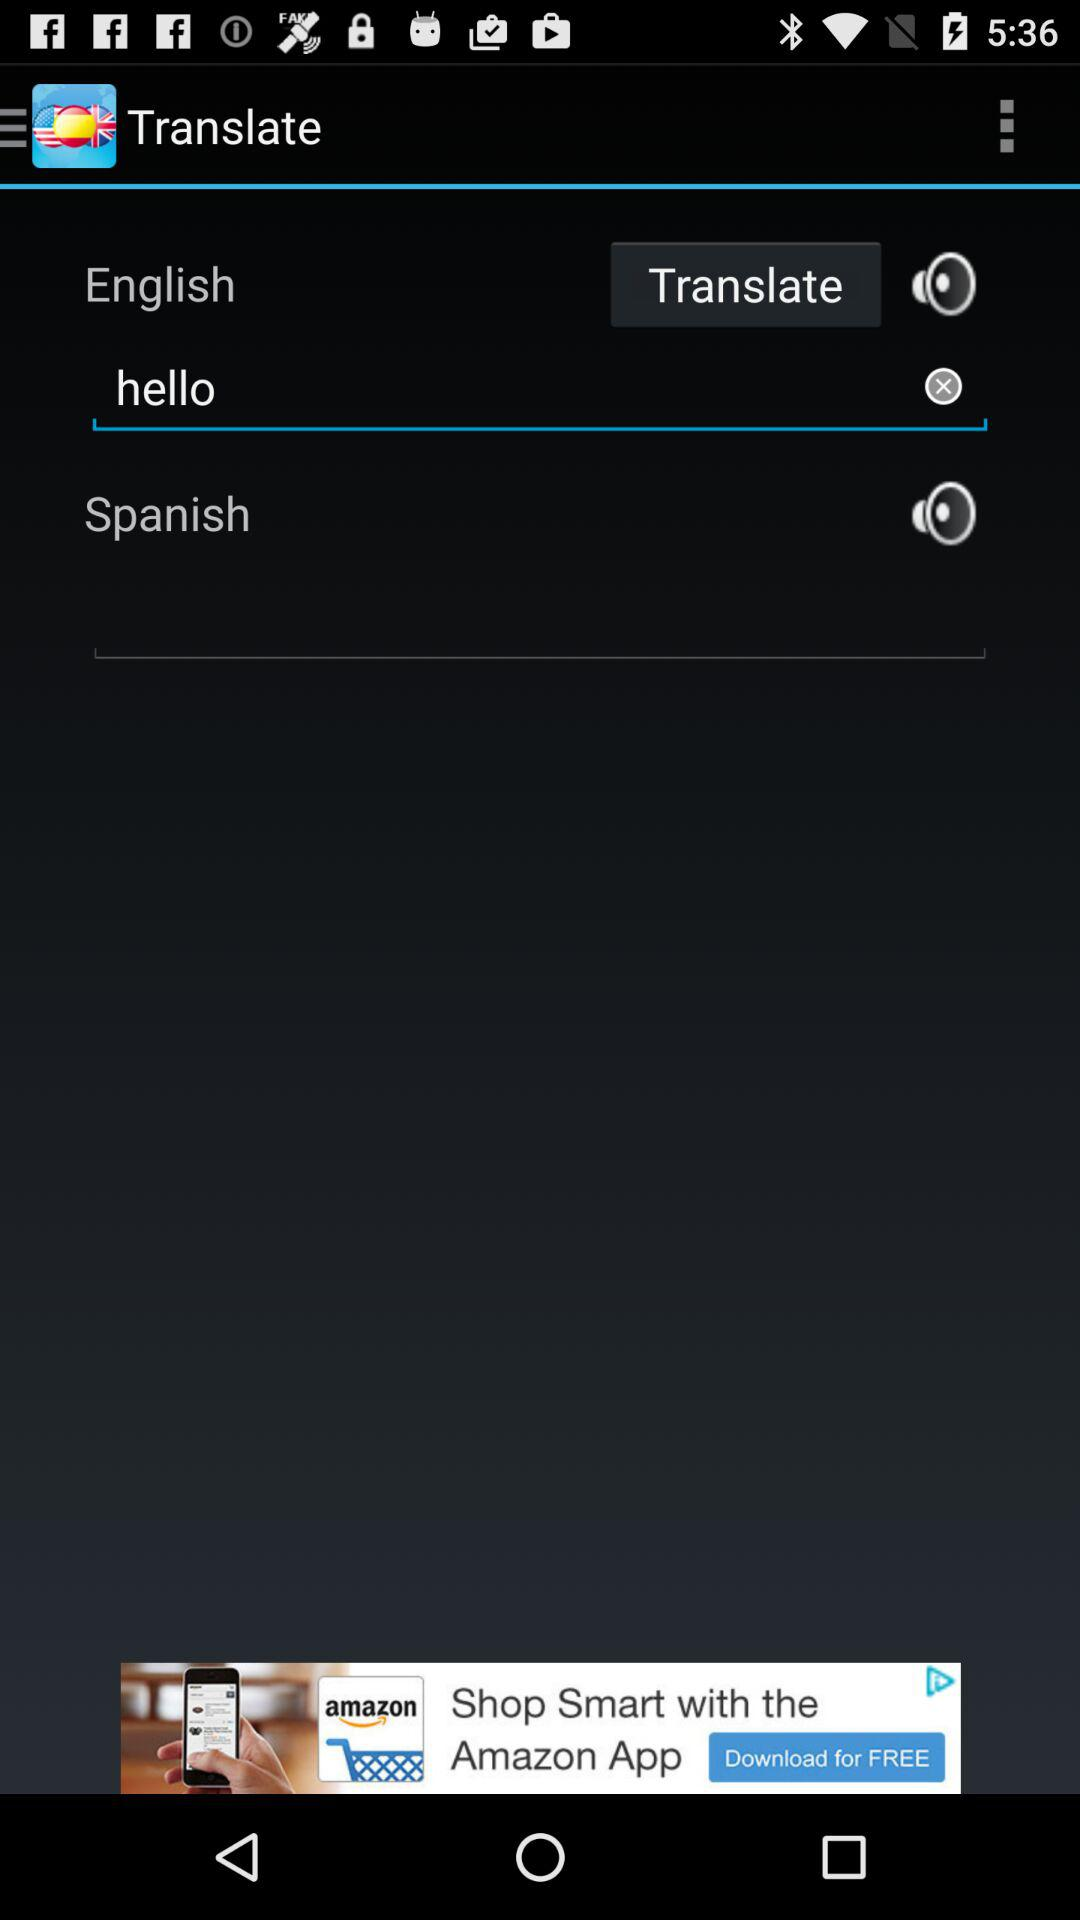What is the application name? The application name is "Spanish English Dictionary". 